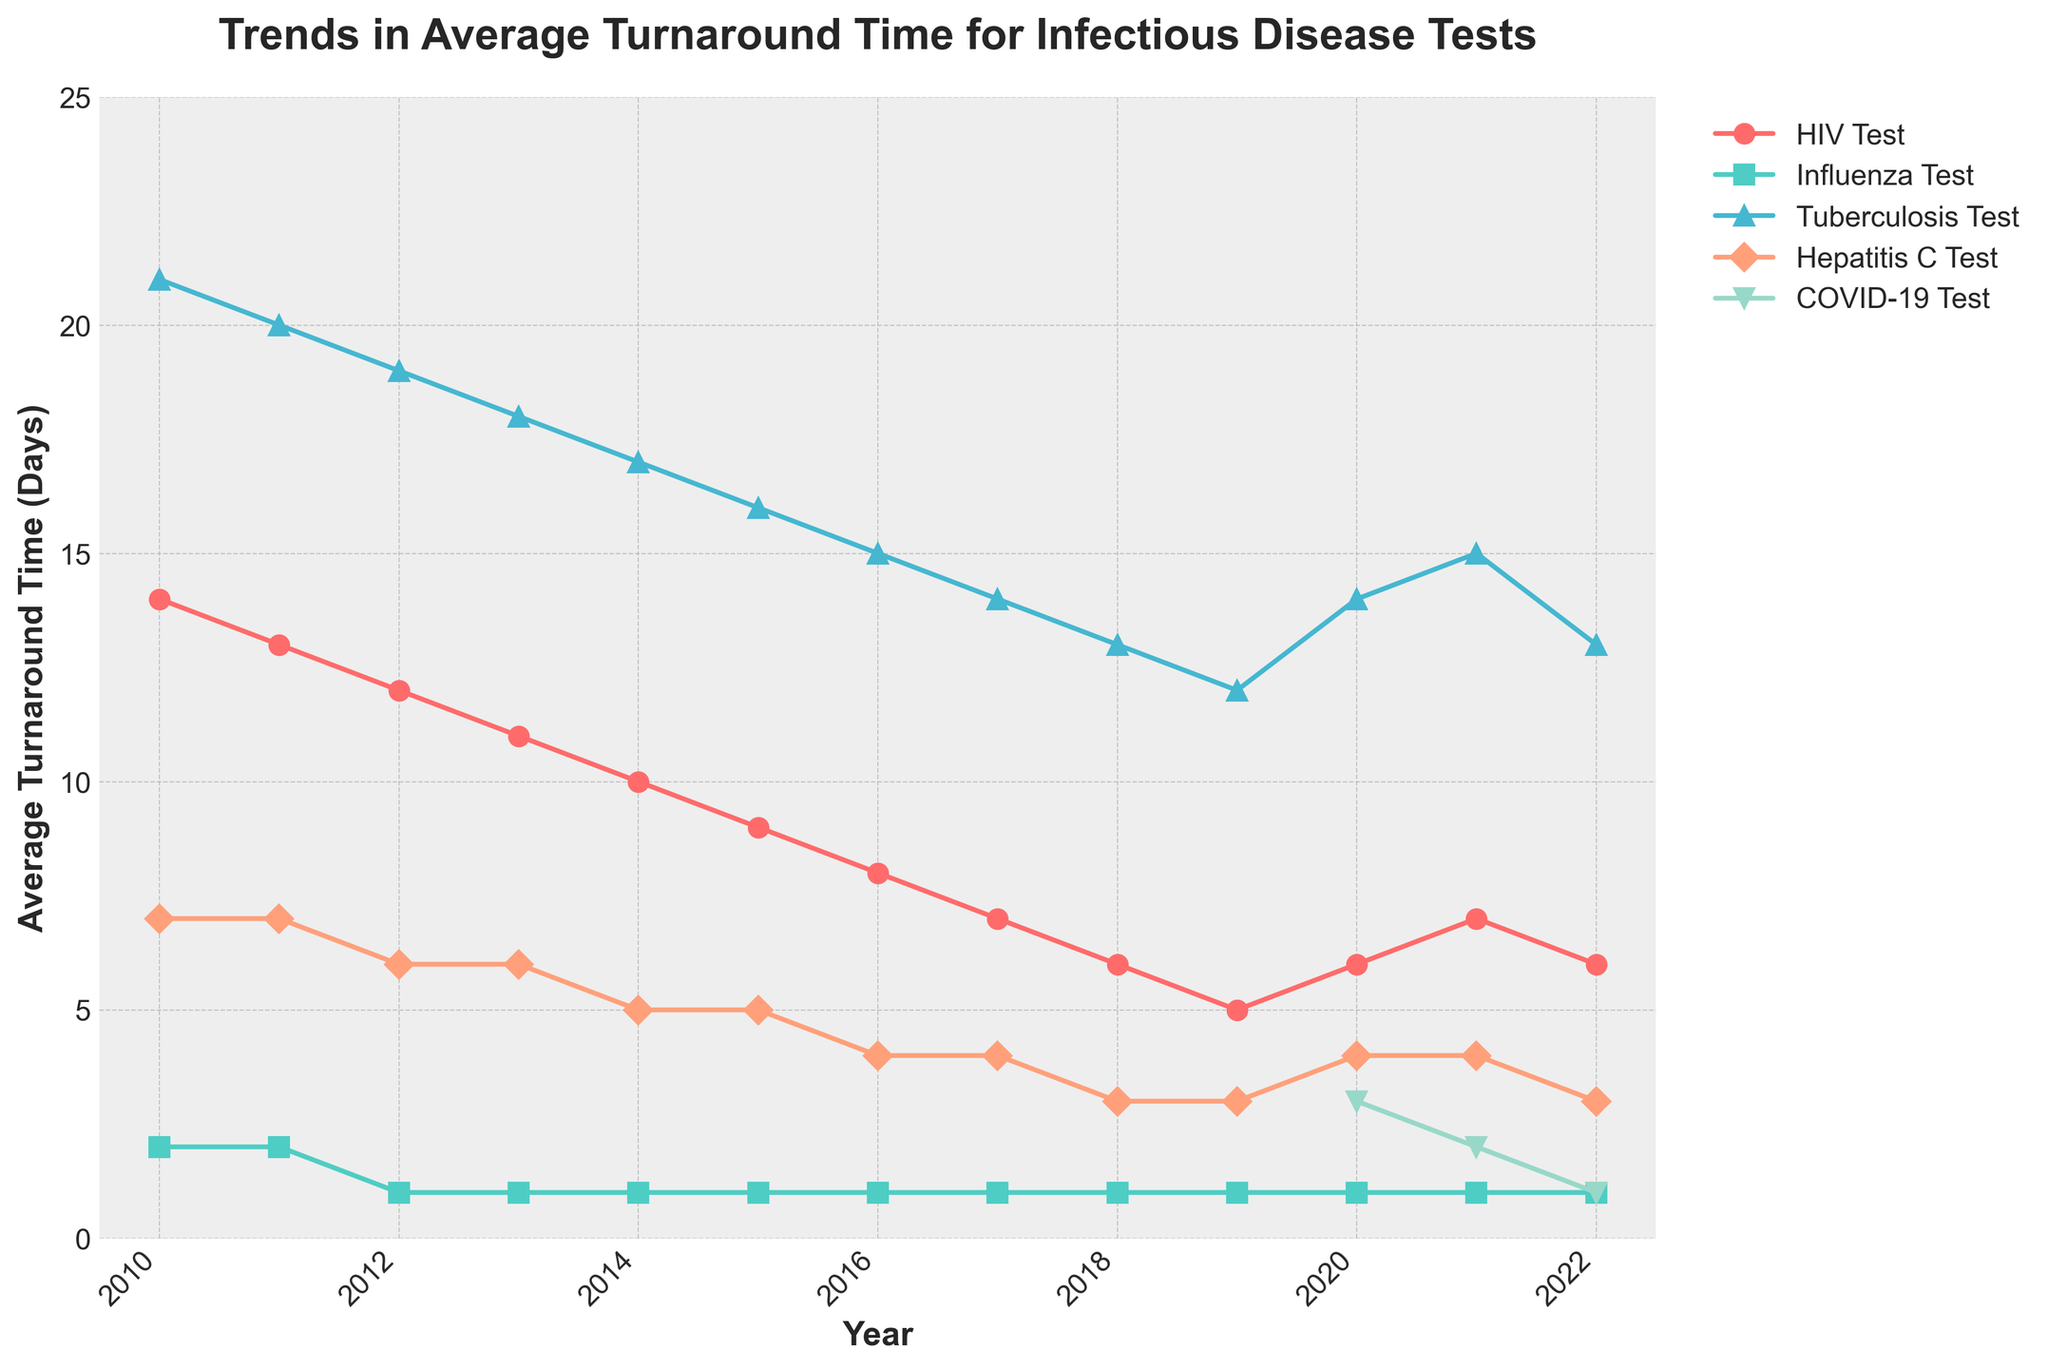Which infectious disease test showed the greatest improvement in average turnaround time since 2010? To determine this, look at the trends for each disease in the chart from 2010 to 2022 and compare the changes. HIV Test reduced from 14 to 6 days, Influenza from 2 to 1 day, Tuberculosis from 21 to 13 days, Hepatitis C from 7 to 3 days, and COVID-19 from 3 to 1 day (starting from 2020). The HIV Test, which improved by 8 days, shows the greatest improvement.
Answer: HIV Test Between 2020 and 2022, which infectious disease test experienced the least amount of fluctuation in turnaround time? Look at the lines representing each test from 2020 to 2022. The lines for Influenza and Tuberculosis are flat, indicating no fluctuations, while HIV Test, Hepatitis C, and COVID-19 have some changes.
Answer: Influenza What's the average turnaround time for the COVID-19 test during its first three years of availability (2020-2022)? List the turnaround times for the COVID-19 test from 2020 to 2022: 3 days, 2 days, and 1 day. Sum these up (3 + 2 + 1 = 6) and divide by 3 (6/3 = 2).
Answer: 2 days Has the turnaround time for Hepatitis C tests consistently decreased since 2010? Trace the Hepatitis C line from 2010 to 2022. The turnaround time decreases consistently from 7 days (2010) to 3 days (2022), confirming a consistent reduction over time.
Answer: Yes Which two tests had the same average turnaround time in 2017? Locate the markers for each test in 2017. Both Influenza and Hepatitis C have a turnaround time of 1 day in 2017.
Answer: Influenza and Hepatitis C How many years did it take for the HIV test turnaround time to fall below 10 days? Follow the HIV Test line and note the year it first drops below 10 days. This occurred in 2014. Since this starts from 2010, it took 4 years.
Answer: 4 years Comparing the trends for Tuberculosis and Hepatitis C from 2015 to 2020, which test showed a steeper reduction in turnaround time? Examine the slopes of the Tuberculosis and Hepatitis C lines from 2015 to 2020. Tuberculosis decreases from 16 to 14 days, reducing by 2 days. Hepatitis C decreases from 5 to 4 days, reducing by 1 day. Therefore, Tuberculosis shows a steeper reduction.
Answer: Tuberculosis If the trend continues, what will be the expected turnaround time for the Influenza test in 2023? The Influenza test has been consistently at 1 day since 2012. Assuming the trend continues, it will still be 1 day in 2023.
Answer: 1 day 